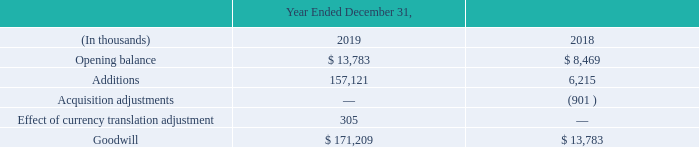1. Goodwill and Other Intangible Assets
The changes in the carrying amount of goodwill for the years ended December 31, 2019 and 2018, are as follows:
Our 2019 acquisitions of DeliverySlip (as defined herein) and AppRiver (as defined herein) resulted in the addition to our goodwill balance in 2019. Our 2018 acquisition of Erado (as defined herein) resulted in the addition to our goodwill balance in 2018. Our 2018 acquisition adjustments to goodwill reflect the appropriate reallocation of excess purchase price from goodwill to acquired assets and liabilities related to our 2017 Greenview and EMS (as defined herein) purchases. We evaluate goodwill for impairment annually in the fourth quarter, or when there is reason to believe that the value has been diminished or impaired. There were no impairment indicators to the goodwill recorded as of December 31, 2019.
Which companies did zix acquire in 2019 and 2018 respectively? Deliveryslip (as defined herein) and appriver (as defined herein), erado. What were the organisations the company purchased in 2017? Greenview, ems. How much was the Opening balance for goodwill and other intangible assets in 2019 and 2018 respectively?
Answer scale should be: thousand. 13,783, 8,469. What is the percentage change in goodwill from 2018 to 2019?
Answer scale should be: percent. (171,209-13,783)/13,783
Answer: 1142.18. From 2018 to 2019, how many years was the Opening balance more than $5,000 thousand? 2018 ## 2019
Answer: 2. How much is the total additions and Acquisition adjustments over 2018 and 2019?
Answer scale should be: thousand. 157,121+6,215-901
Answer: 162435. 